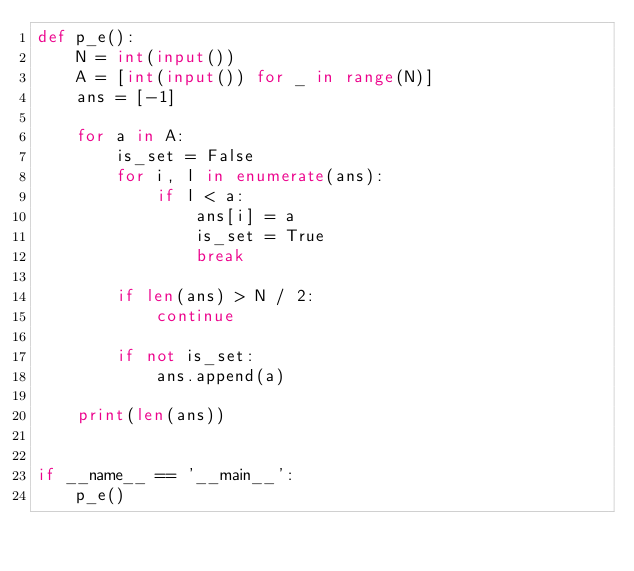Convert code to text. <code><loc_0><loc_0><loc_500><loc_500><_Python_>def p_e():
    N = int(input())
    A = [int(input()) for _ in range(N)]
    ans = [-1]

    for a in A:
        is_set = False
        for i, l in enumerate(ans):
            if l < a:
                ans[i] = a
                is_set = True
                break

        if len(ans) > N / 2:
            continue

        if not is_set:
            ans.append(a)

    print(len(ans))


if __name__ == '__main__':
    p_e()</code> 